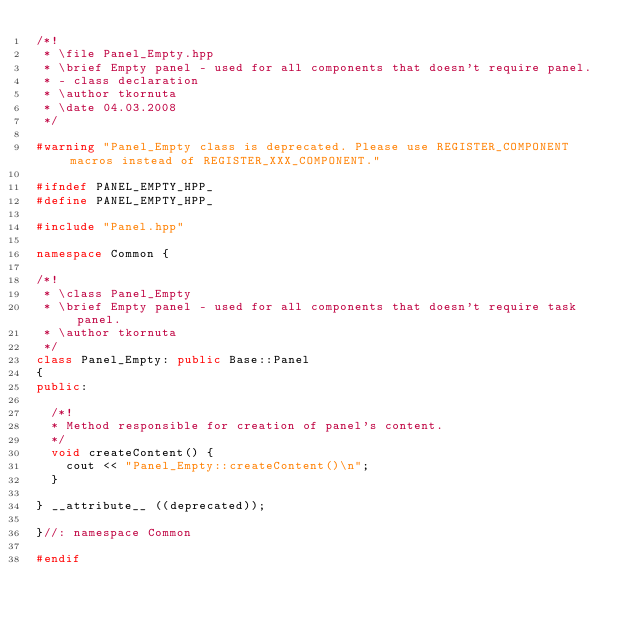Convert code to text. <code><loc_0><loc_0><loc_500><loc_500><_C++_>/*!
 * \file Panel_Empty.hpp
 * \brief Empty panel - used for all components that doesn't require panel.
 * - class declaration
 * \author tkornuta
 * \date 04.03.2008
 */

#warning "Panel_Empty class is deprecated. Please use REGISTER_COMPONENT macros instead of REGISTER_XXX_COMPONENT."

#ifndef PANEL_EMPTY_HPP_
#define PANEL_EMPTY_HPP_

#include "Panel.hpp"

namespace Common {

/*!
 * \class Panel_Empty
 * \brief Empty panel - used for all components that doesn't require task panel.
 * \author tkornuta
 */
class Panel_Empty: public Base::Panel
{
public:

	/*!
	* Method responsible for creation of panel's content.
	*/
	void createContent() {
		cout << "Panel_Empty::createContent()\n";
	}

} __attribute__ ((deprecated));

}//: namespace Common

#endif
</code> 